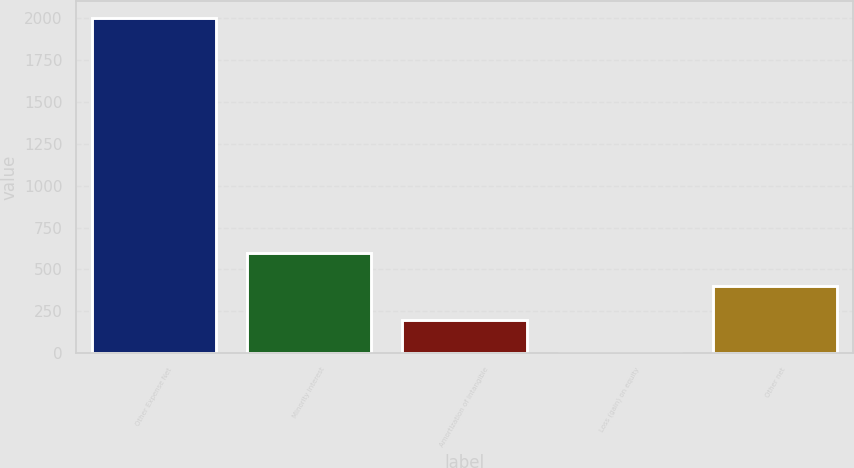Convert chart to OTSL. <chart><loc_0><loc_0><loc_500><loc_500><bar_chart><fcel>Other Expense Net<fcel>Minority interest<fcel>Amortization of intangible<fcel>Loss (gain) on equity<fcel>Other net<nl><fcel>2002<fcel>601.02<fcel>200.74<fcel>0.6<fcel>400.88<nl></chart> 